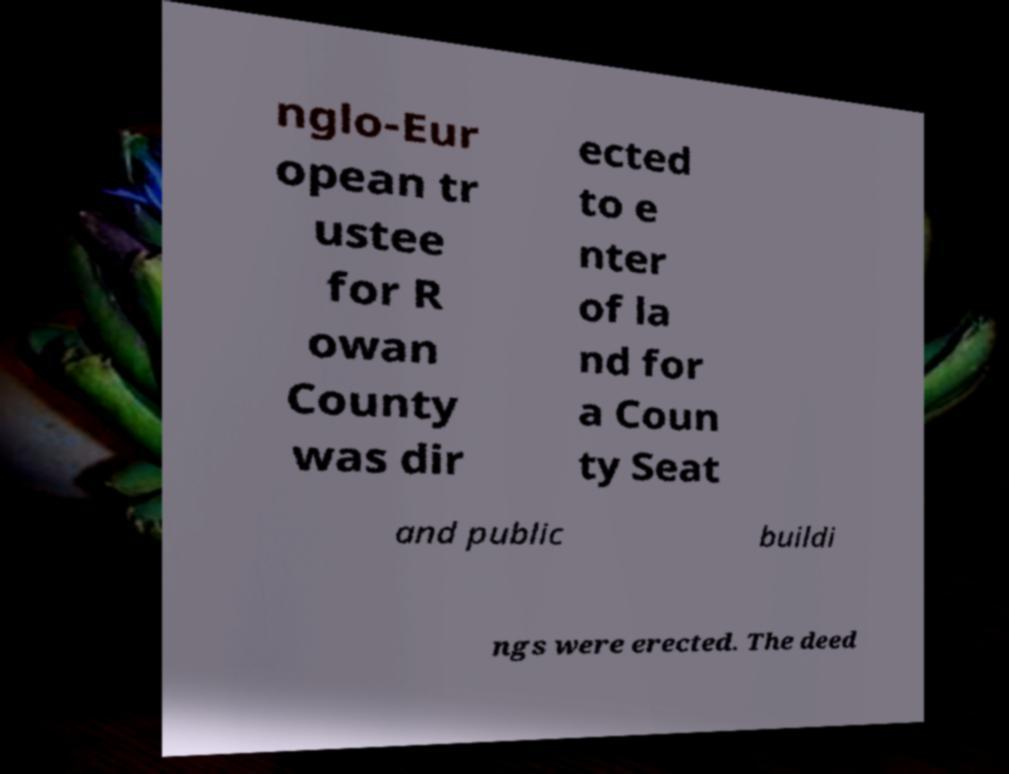What messages or text are displayed in this image? I need them in a readable, typed format. nglo-Eur opean tr ustee for R owan County was dir ected to e nter of la nd for a Coun ty Seat and public buildi ngs were erected. The deed 